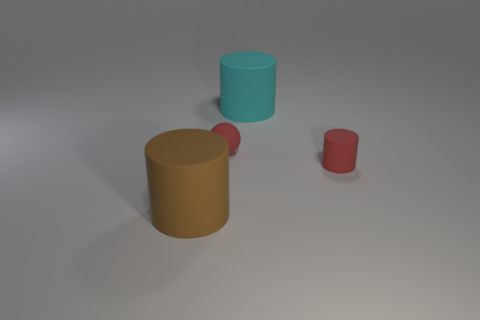Add 2 large brown matte objects. How many objects exist? 6 Subtract all spheres. How many objects are left? 3 Subtract all red rubber balls. Subtract all large cyan matte cylinders. How many objects are left? 2 Add 3 big cyan matte objects. How many big cyan matte objects are left? 4 Add 2 big brown rubber cylinders. How many big brown rubber cylinders exist? 3 Subtract 0 yellow cubes. How many objects are left? 4 